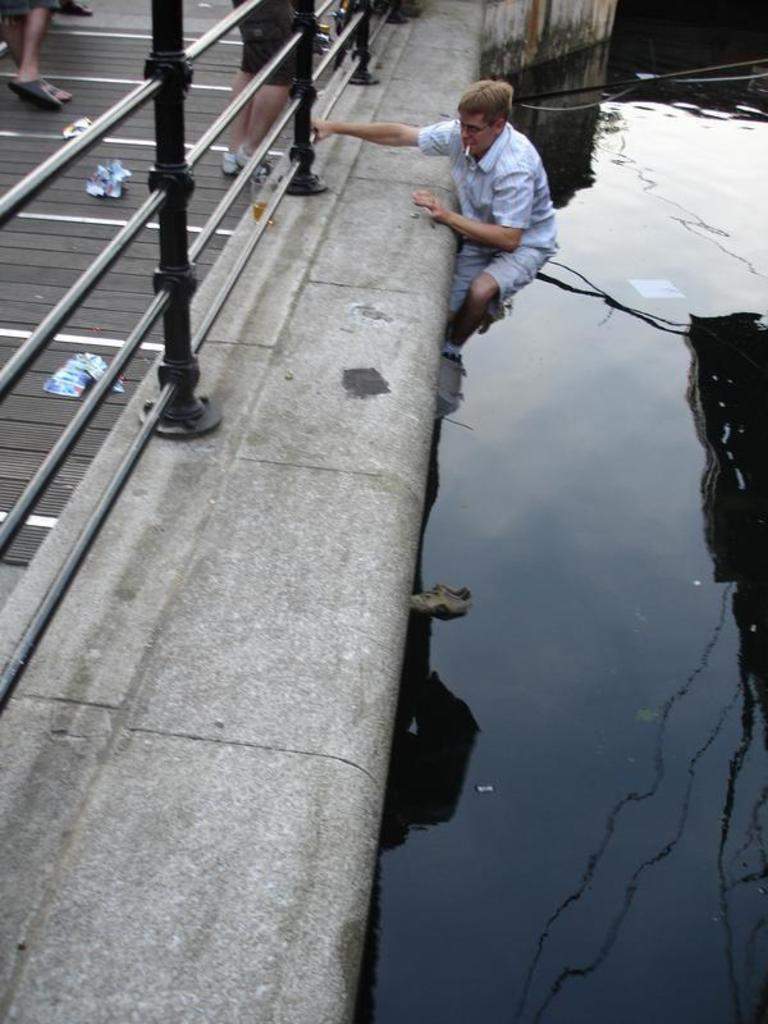What type of structure is present along the path in the image? There is a railing along the path in the image. What can be seen beside the path? Water is visible beside the path. What is the man in the image doing? The man is climbing the path from the water. What is the man wearing? The man is wearing a white shirt. What type of birthday celebration is taking place in the image? There is no indication of a birthday celebration in the image. How does the man's cough affect his ability to climb the path? There is no mention of the man coughing in the image, so it cannot be determined how it would affect his ability to climb the path. 